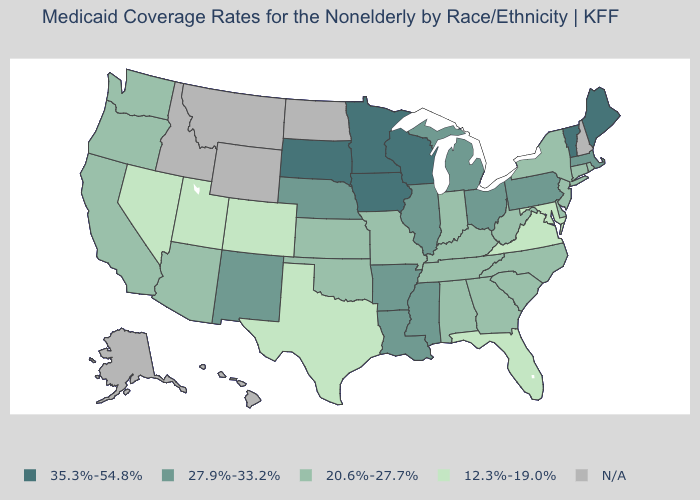Name the states that have a value in the range 27.9%-33.2%?
Short answer required. Arkansas, Illinois, Louisiana, Massachusetts, Michigan, Mississippi, Nebraska, New Mexico, Ohio, Pennsylvania. What is the value of Arkansas?
Quick response, please. 27.9%-33.2%. What is the highest value in the USA?
Be succinct. 35.3%-54.8%. What is the value of Illinois?
Give a very brief answer. 27.9%-33.2%. Name the states that have a value in the range 20.6%-27.7%?
Be succinct. Alabama, Arizona, California, Connecticut, Delaware, Georgia, Indiana, Kansas, Kentucky, Missouri, New Jersey, New York, North Carolina, Oklahoma, Oregon, Rhode Island, South Carolina, Tennessee, Washington, West Virginia. What is the highest value in states that border Nebraska?
Keep it brief. 35.3%-54.8%. Name the states that have a value in the range 12.3%-19.0%?
Concise answer only. Colorado, Florida, Maryland, Nevada, Texas, Utah, Virginia. What is the value of Florida?
Answer briefly. 12.3%-19.0%. Name the states that have a value in the range 12.3%-19.0%?
Short answer required. Colorado, Florida, Maryland, Nevada, Texas, Utah, Virginia. Name the states that have a value in the range N/A?
Short answer required. Alaska, Hawaii, Idaho, Montana, New Hampshire, North Dakota, Wyoming. What is the value of Texas?
Write a very short answer. 12.3%-19.0%. Name the states that have a value in the range 35.3%-54.8%?
Concise answer only. Iowa, Maine, Minnesota, South Dakota, Vermont, Wisconsin. Name the states that have a value in the range 12.3%-19.0%?
Answer briefly. Colorado, Florida, Maryland, Nevada, Texas, Utah, Virginia. Among the states that border New Jersey , which have the lowest value?
Short answer required. Delaware, New York. 